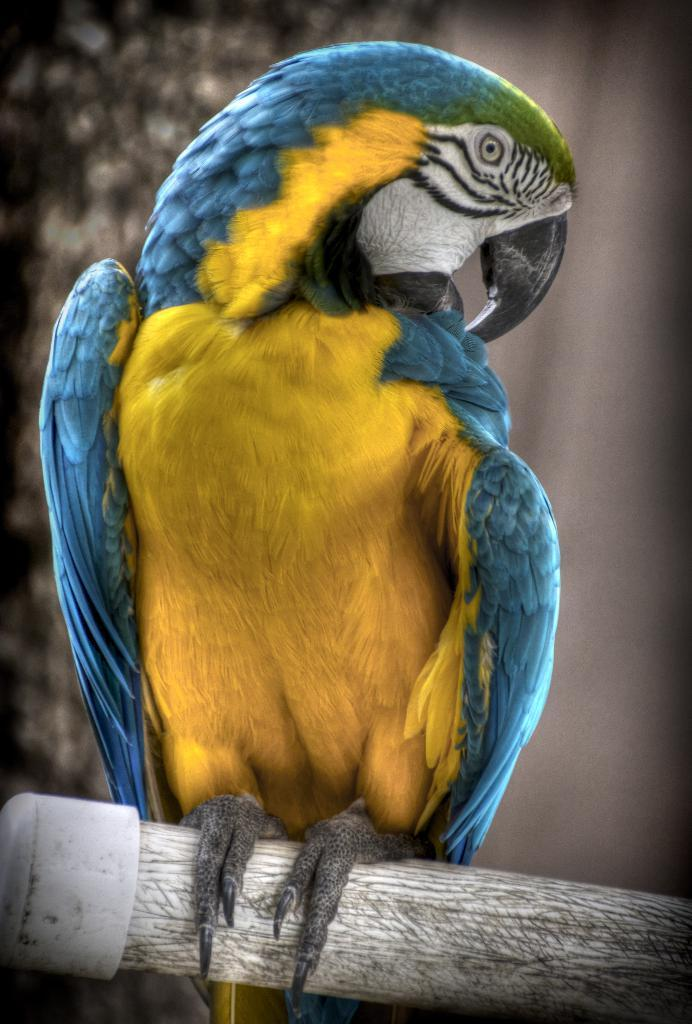What type of animal is in the image? There is a bird in the image. Where is the bird located? The bird is on a wooden stick. What type of metal is the bird giving birth to on the side of the wooden stick? There is no metal or birth depicted in the image; it features a bird on a wooden stick. 